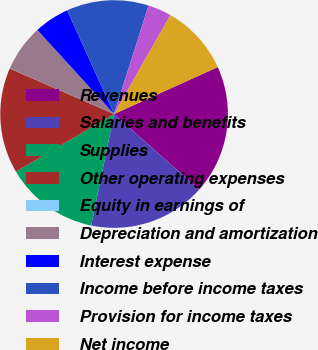<chart> <loc_0><loc_0><loc_500><loc_500><pie_chart><fcel>Revenues<fcel>Salaries and benefits<fcel>Supplies<fcel>Other operating expenses<fcel>Equity in earnings of<fcel>Depreciation and amortization<fcel>Interest expense<fcel>Income before income taxes<fcel>Provision for income taxes<fcel>Net income<nl><fcel>18.32%<fcel>16.66%<fcel>13.33%<fcel>14.99%<fcel>0.01%<fcel>6.67%<fcel>5.01%<fcel>11.66%<fcel>3.34%<fcel>10.0%<nl></chart> 